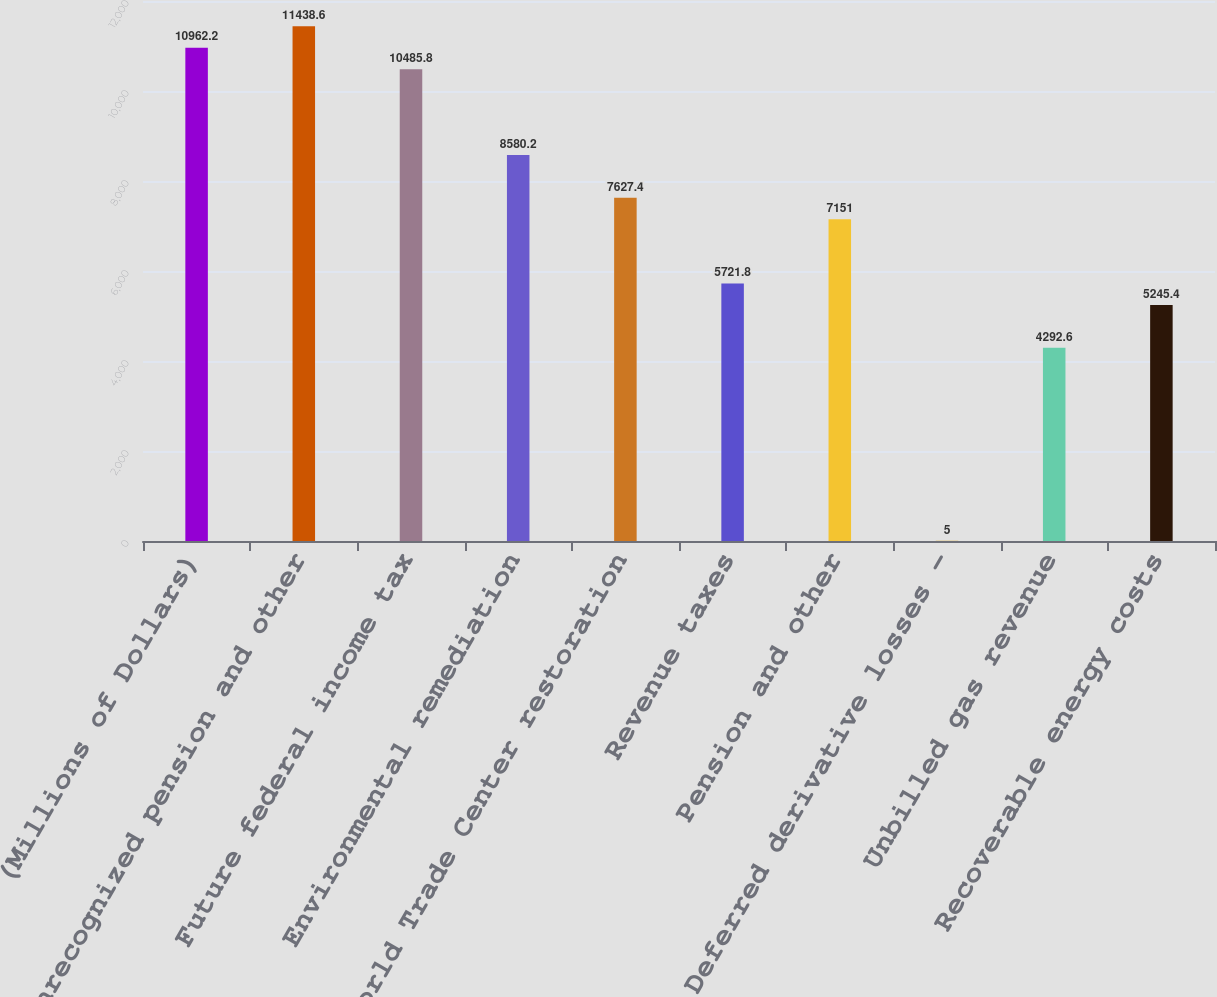<chart> <loc_0><loc_0><loc_500><loc_500><bar_chart><fcel>(Millions of Dollars)<fcel>Unrecognized pension and other<fcel>Future federal income tax<fcel>Environmental remediation<fcel>World Trade Center restoration<fcel>Revenue taxes<fcel>Pension and other<fcel>Deferred derivative losses -<fcel>Unbilled gas revenue<fcel>Recoverable energy costs<nl><fcel>10962.2<fcel>11438.6<fcel>10485.8<fcel>8580.2<fcel>7627.4<fcel>5721.8<fcel>7151<fcel>5<fcel>4292.6<fcel>5245.4<nl></chart> 